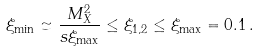Convert formula to latex. <formula><loc_0><loc_0><loc_500><loc_500>\xi _ { \min } \simeq \frac { M _ { X } ^ { 2 } } { s \xi _ { \max } } \leq \xi _ { 1 , 2 } \leq \xi _ { \max } = 0 . 1 \, .</formula> 